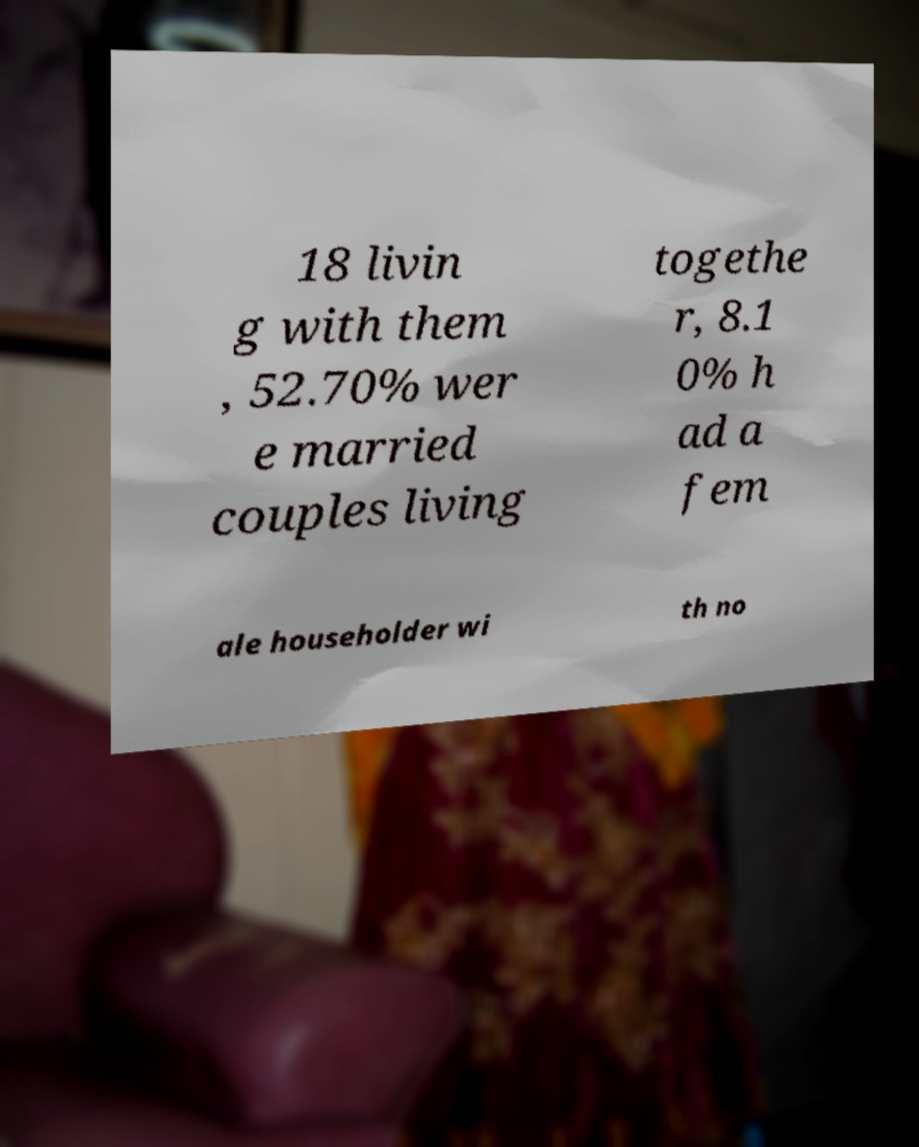Please identify and transcribe the text found in this image. 18 livin g with them , 52.70% wer e married couples living togethe r, 8.1 0% h ad a fem ale householder wi th no 